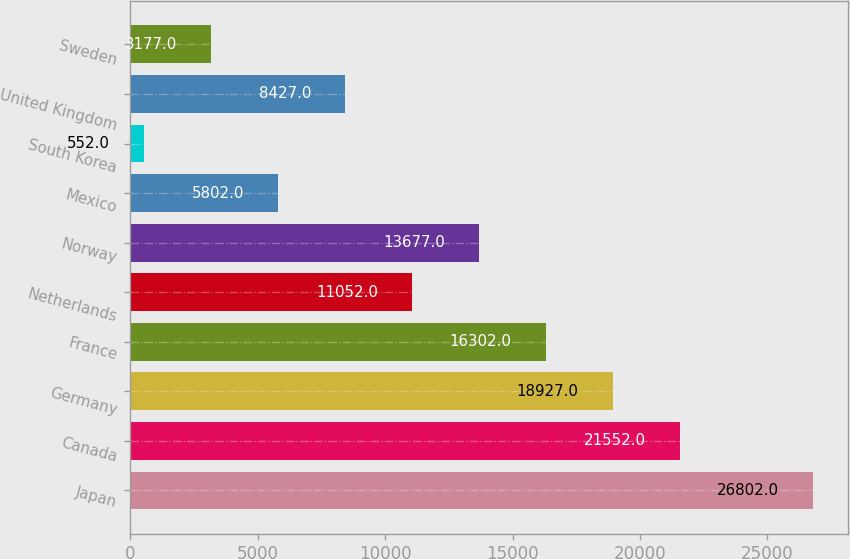Convert chart to OTSL. <chart><loc_0><loc_0><loc_500><loc_500><bar_chart><fcel>Japan<fcel>Canada<fcel>Germany<fcel>France<fcel>Netherlands<fcel>Norway<fcel>Mexico<fcel>South Korea<fcel>United Kingdom<fcel>Sweden<nl><fcel>26802<fcel>21552<fcel>18927<fcel>16302<fcel>11052<fcel>13677<fcel>5802<fcel>552<fcel>8427<fcel>3177<nl></chart> 